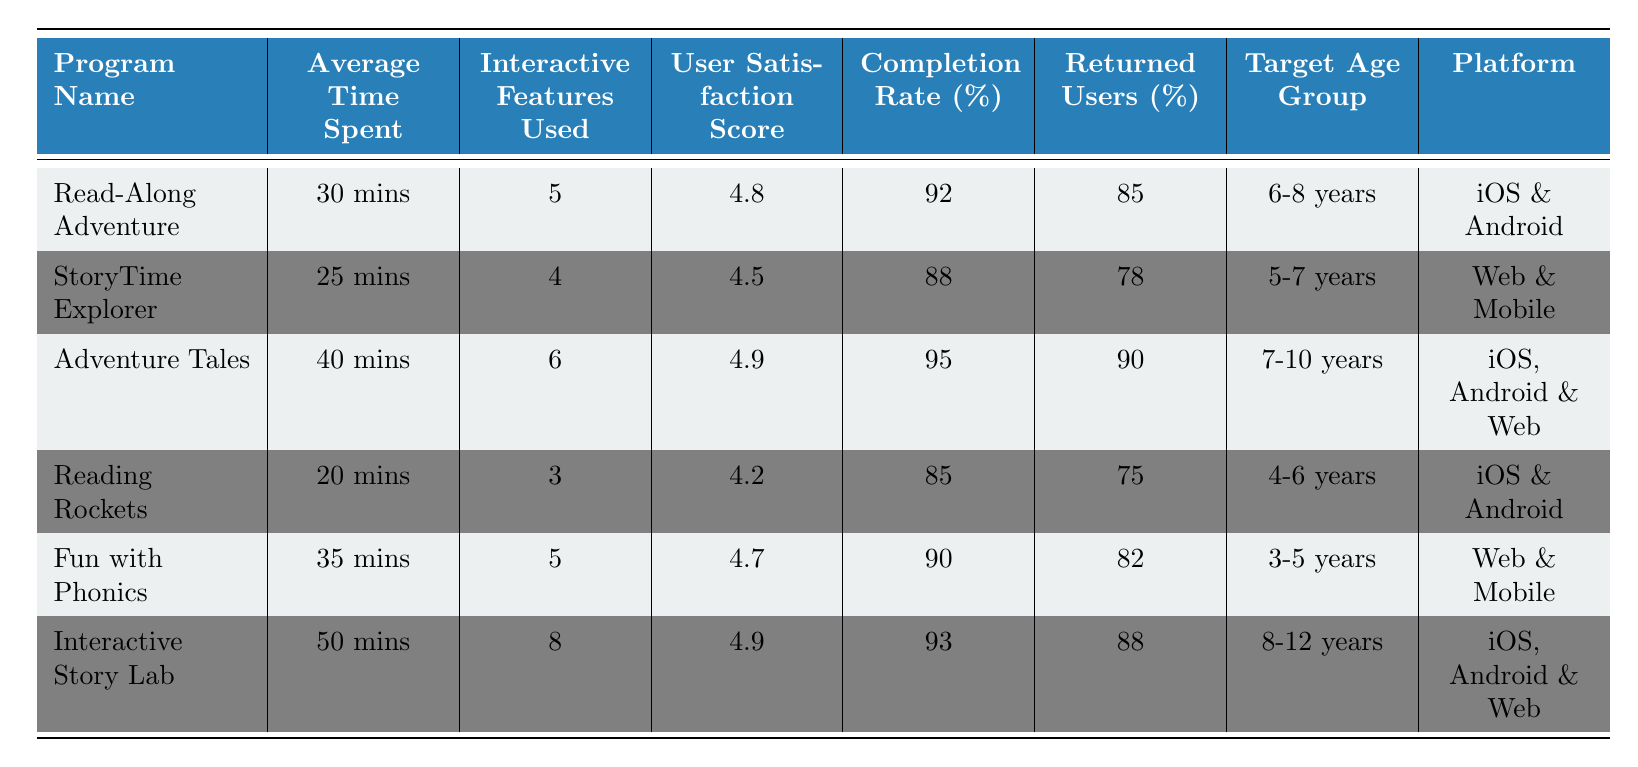What is the average time spent on the program "Adventure Tales"? The table lists the program "Adventure Tales," and the average time spent is directly mentioned as "40 mins."
Answer: 40 mins Which reading program has the highest user satisfaction score? Looking through the user satisfaction scores for each program, "Adventure Tales" has the highest score of 4.9 compared to other programs.
Answer: Adventure Tales What is the completion rate of the "Reading Rockets" program? The table specifies the completion rate for "Reading Rockets" as 85 percent.
Answer: 85 Do all programs target users under 12 years old? By checking the target age groups for all programs, all listed programs target age groups that are less than or equal to 12 years old.
Answer: Yes What is the average number of interactive features used across all programs? First, we sum the interactive features used: 5 + 4 + 6 + 3 + 5 + 8 = 31. Then, we divide by the number of programs, which is 6. So, 31/6 equals approximately 5.17.
Answer: 5.17 Which program has the least number of returned users, and what percentage is it? By reviewing the returned users' percentages for each program, "Reading Rockets" has the least at 75 percent.
Answer: Reading Rockets, 75 Is the platform for "Fun with Phonics" only available on mobile devices? The table states the platform for "Fun with Phonics" is "Web & Mobile," indicating it is not limited to mobile devices.
Answer: No What is the difference in completion rates between "Interactive Story Lab" and "StoryTime Explorer"? The completion rate for "Interactive Story Lab" is 93 percent, and for "StoryTime Explorer," it is 88 percent. The difference is 93 - 88 = 5 percent.
Answer: 5 How many programs have a user satisfaction score of 4.5 or higher? By reviewing the user satisfaction scores in the table, the following programs have scores of 4.5 or higher: "Read-Along Adventure," "Adventure Tales," "Fun with Phonics," and "Interactive Story Lab," totaling four programs.
Answer: 4 